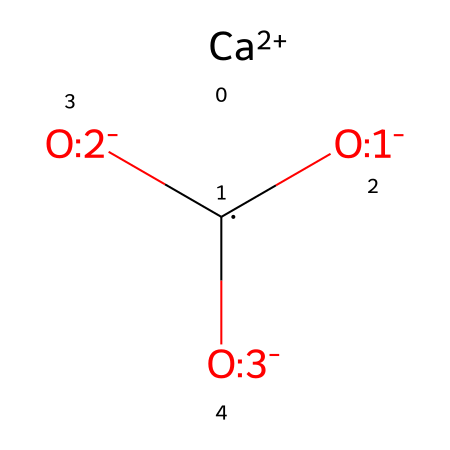What is the calcium ion's charge in this structure? The chemical representation indicates a calcium ion represented by [Ca+2], which shows that it has a 2+ charge.
Answer: 2+ How many oxygen atoms are present in the calcium carbonate structure? The structure includes three oxygen atoms, identifiable from the notation ([O-:1], [O-:2], [O-:3]), which explicitly indicates three oxygen components.
Answer: 3 What is the molecular formula of calcium carbonate based on this structure? Analyzing the components of the chemical structure, it consists of one calcium ion, one carbon atom, and three oxygen atoms, leading to the molecular formula CaCO3.
Answer: CaCO3 What type of solid is calcium carbonate? Calcium carbonate is primarily a mineral compound, which is defined as an inorganic solid that occurs naturally in the earth's crust.
Answer: mineral How does the coordination of calcium ions affect the stability of the structure? The calcium ion's 2+ charge allows it to stabilize the structure by forming ionic bonds with the carbonate anion. This charge balance contributes to the overall stability of the calcium carbonate solid.
Answer: stability What type of bonding exists between the calcium and carbonate ions? The bonding between calcium ions and carbonate ions is ionic bonding due to the transfer of electrons from calcium to the carbonate.
Answer: ionic What role does calcium carbonate play in juggling balls? Calcium carbonate is used in juggling balls as a filler or as part of the materials that give the balls weight and durability.
Answer: filler 